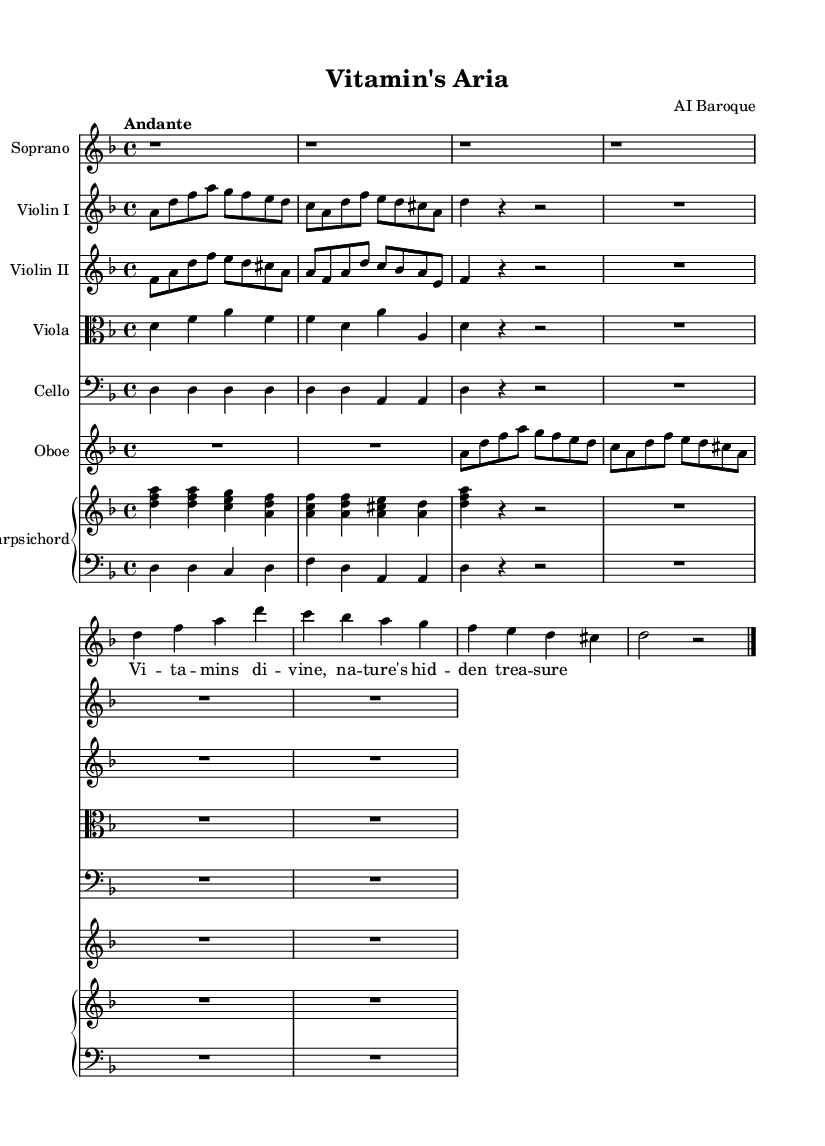What is the key signature of this music? The key signature is indicated right after the clef, showing two flats (B and E). This means the piece is in D minor, as D minor has one flat in its key signature (the B flat).
Answer: D minor What is the time signature of this music? The time signature is found at the beginning of the piece and is indicated by the numbers 4 over 4. This means there are four beats in each measure, and each beat is a quarter note.
Answer: 4/4 What is the tempo marking for this piece? The tempo marking is found at the beginning of the score and reads "Andante." This indicates the piece should be played at a moderately slow pace.
Answer: Andante How many measures are there in the soprano part? By counting the vertical bar lines in the soprano part, there are a total of four measures, as each measure is separated by these lines.
Answer: 4 What instrument has the clef set to alto? The viola part is set to the alto clef, indicated by the clef symbol specified at the beginning of the viola staff. This clef is primarily used for instruments that play in the mid-range, such as the viola.
Answer: Viola What lyrical theme does the soprano part express? The lyrics in the soprano part reference "vitamins divine, nature's hidden treasure," suggesting a thematic focus on the significance of vitamins and their natural origins. This theme relates directly to the title of the aria and the overall message of the opera.
Answer: Vitamins divine How many instruments are present in the score? By reviewing each staff line in the score, there are six uniquely named instruments along with the harpsichord, which is divided into right and left staves for accompaniment. Thus, there are a total of seven instrumental parts.
Answer: 7 